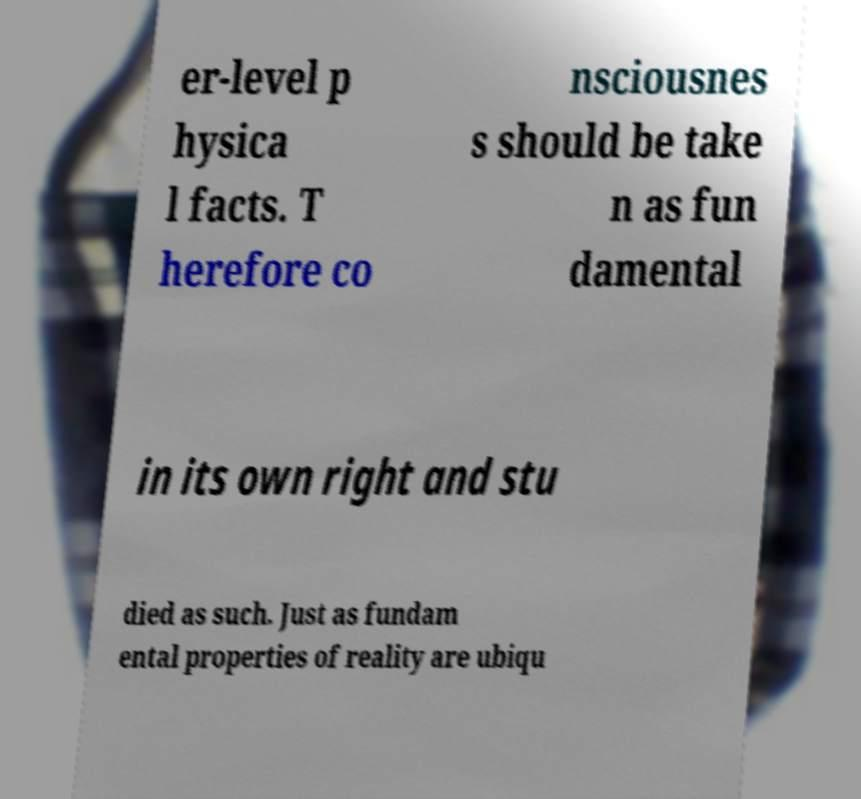What messages or text are displayed in this image? I need them in a readable, typed format. er-level p hysica l facts. T herefore co nsciousnes s should be take n as fun damental in its own right and stu died as such. Just as fundam ental properties of reality are ubiqu 